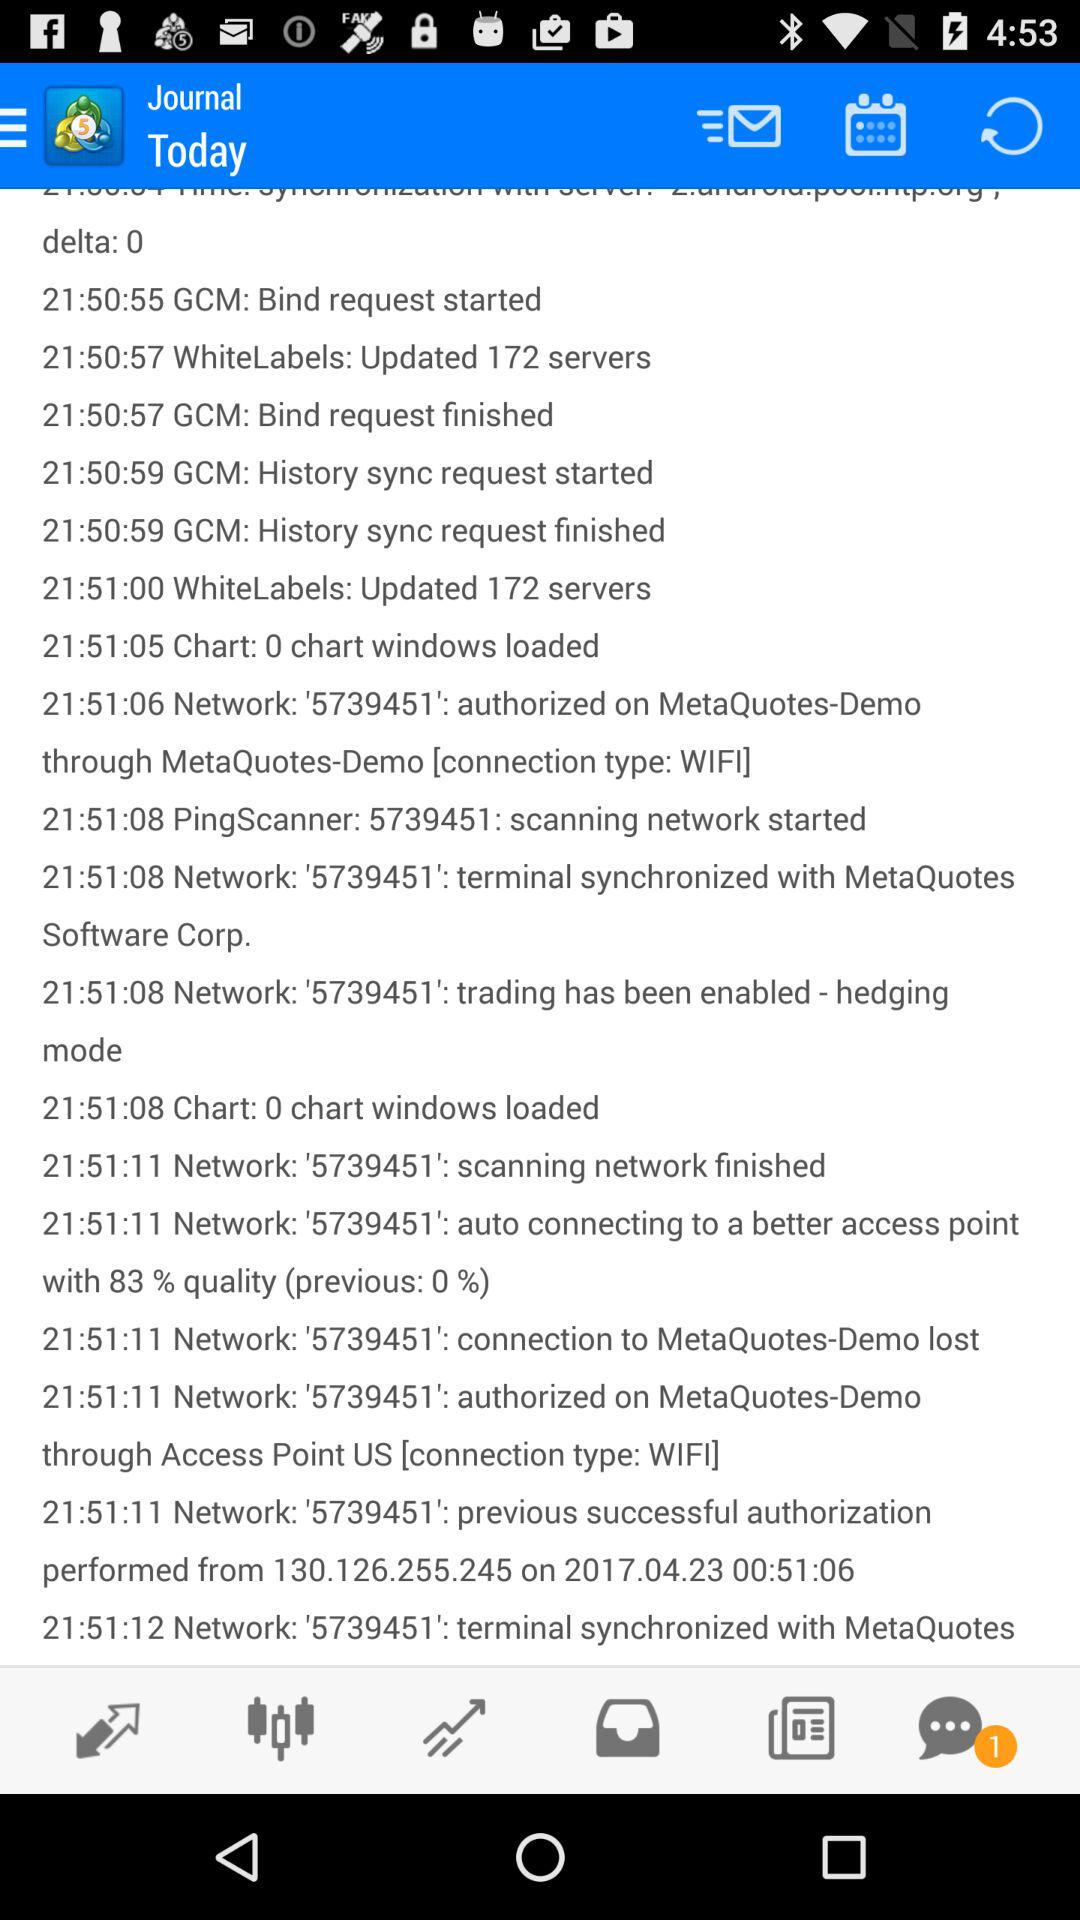How many chat notifications are there? There is 1 chat notification. 